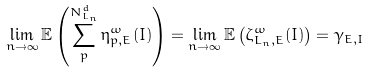Convert formula to latex. <formula><loc_0><loc_0><loc_500><loc_500>\lim _ { n \to \infty } \mathbb { E } \left ( \sum _ { p } ^ { N _ { L _ { n } } ^ { d } } \eta ^ { \omega } _ { p , E } ( I ) \right ) = \lim _ { n \to \infty } \mathbb { E } \left ( \zeta ^ { \omega } _ { L _ { n } , E } ( I ) \right ) = \gamma _ { E , I } \\</formula> 